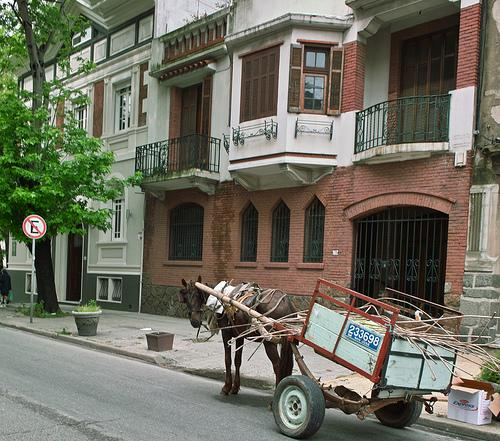Why is the horse attached to the cart with wheels?

Choices:
A) to punish
B) to pull
C) to eat
D) to heal to pull 